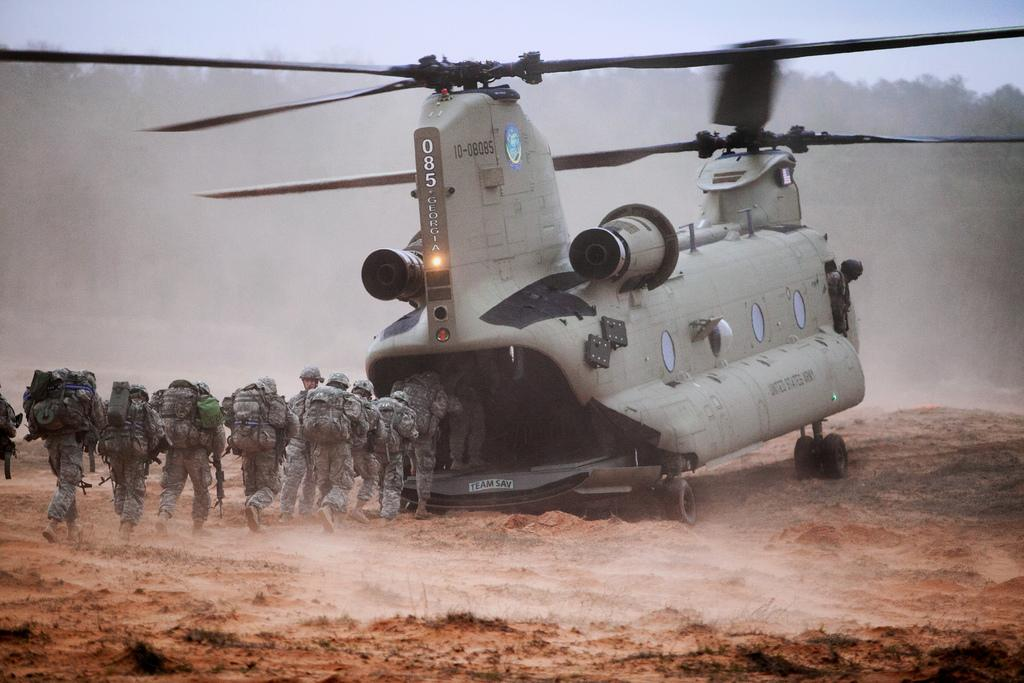What is the main subject of the image? The main subject of the image is an airplane on the ground. What are the people in the image doing? The people in the image are running towards the airplane. What are the people carrying? The people are carrying bags. What can be seen in the background of the image? There are trees visible in the background of the image. Can you tell me how many giraffes are visible in the image? There are no giraffes present in the image. What type of hook is being used to secure the airplane to the ground? There is no hook visible in the image; the airplane is on the ground without any visible means of attachment. 